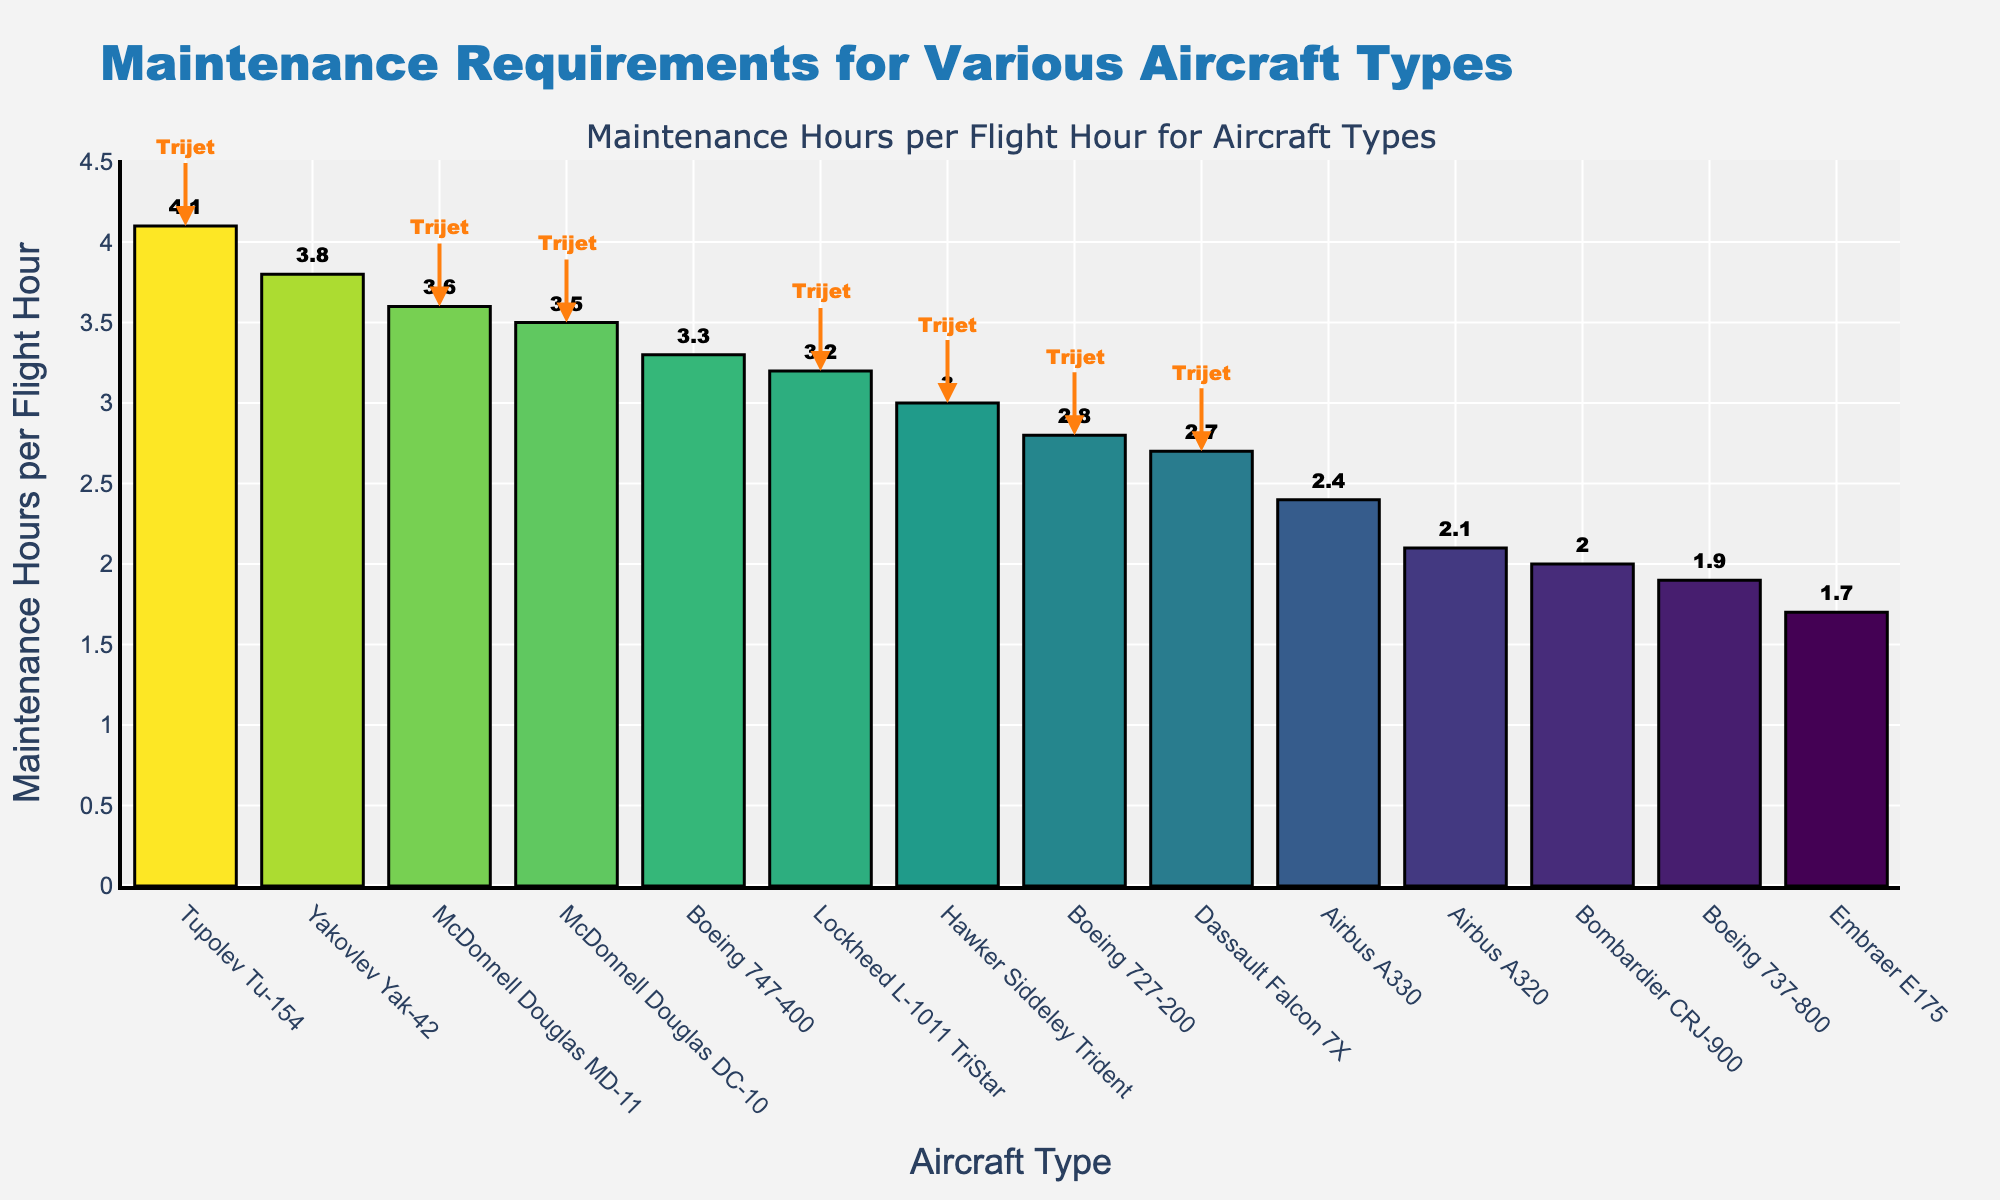Which aircraft type requires the most maintenance hours per flight hour? The maximum maintenance hours per flight hour can be identified by looking for the tallest bar in the chart. The chart shows that the 'Tupolev Tu-154' has the highest maintenance hours per flight hour at 4.1.
Answer: Tupolev Tu-154 Which aircraft type requires the least maintenance hours per flight hour? The least maintenance hours per flight hour can be identified by looking for the shortest bar in the chart. The chart shows that the 'Embraer E175' has the lowest maintenance hours per flight hour at 1.7.
Answer: Embraer E175 How many trijet models are annotated in the plot? By counting the number of annotations labeled as 'Trijet' in the plot, we see annotations for the 'Boeing 727-200', 'Lockheed L-1011 TriStar', 'McDonnell Douglas DC-10', 'Dassault Falcon 7X', 'Hawker Siddeley Trident', 'Tupolev Tu-154', and 'McDonnell Douglas MD-11', totaling 7 trijet models.
Answer: 7 Which aircraft type has the closest maintenance hours per flight hour to the 'Boeing 737-800'? By looking at the bar heights near the 'Boeing 737-800' which has 1.9 hours, the 'Bombardier CRJ-900' with 2.0 hours is the closest.
Answer: Bombardier CRJ-900 What is the average maintenance hours per flight hour for the trijet models listed? The trijet models are 'Boeing 727-200' (2.8), 'Lockheed L-1011 TriStar' (3.2), 'McDonnell Douglas DC-10' (3.5), 'Dassault Falcon 7X' (2.7), 'Hawker Siddeley Trident' (3.0), 'Tupolev Tu-154' (4.1), and 'McDonnell Douglas MD-11' (3.6). Summing them up gives 2.8 + 3.2 + 3.5 + 2.7 + 3.0 + 4.1 + 3.6 = 22.9. The average is 22.9 / 7 = 3.27.
Answer: 3.27 Compare the maintenance hours per flight hour between the 'McDonnell Douglas DC-10' and the 'Airbus A320'. What is the difference? The 'McDonnell Douglas DC-10' has 3.5 hours while the 'Airbus A320' has 2.1 hours. The difference is 3.5 - 2.1 = 1.4 hours.
Answer: 1.4 Which trijet model has the highest maintenance hours per flight hour and what is its value? Among the trijet models, 'Tupolev Tu-154' has the highest maintenance hours per flight hour at 4.1, which is seen by finding the tallest annotated 'Trijet' bar.
Answer: Tupolev Tu-154, 4.1 Which two aircraft types have maintenance hours per flight hour closest to each other, and what are their values? By identifying bars with similar heights, the 'Airbus A320' with 2.1 and the 'Bombardier CRJ-900' with 2.0 have the closest values to each other, differing by just 0.1 hours.
Answer: Airbus A320 (2.1) and Bombardier CRJ-900 (2.0) What is the range of the maintenance hours per flight hour across all aircraft types in the chart? The range is calculated by subtracting the minimum value from the maximum value. The maximum value is 4.1 (Tupolev Tu-154) and the minimum value is 1.7 (Embraer E175). The range is 4.1 - 1.7 = 2.4 hours.
Answer: 2.4 